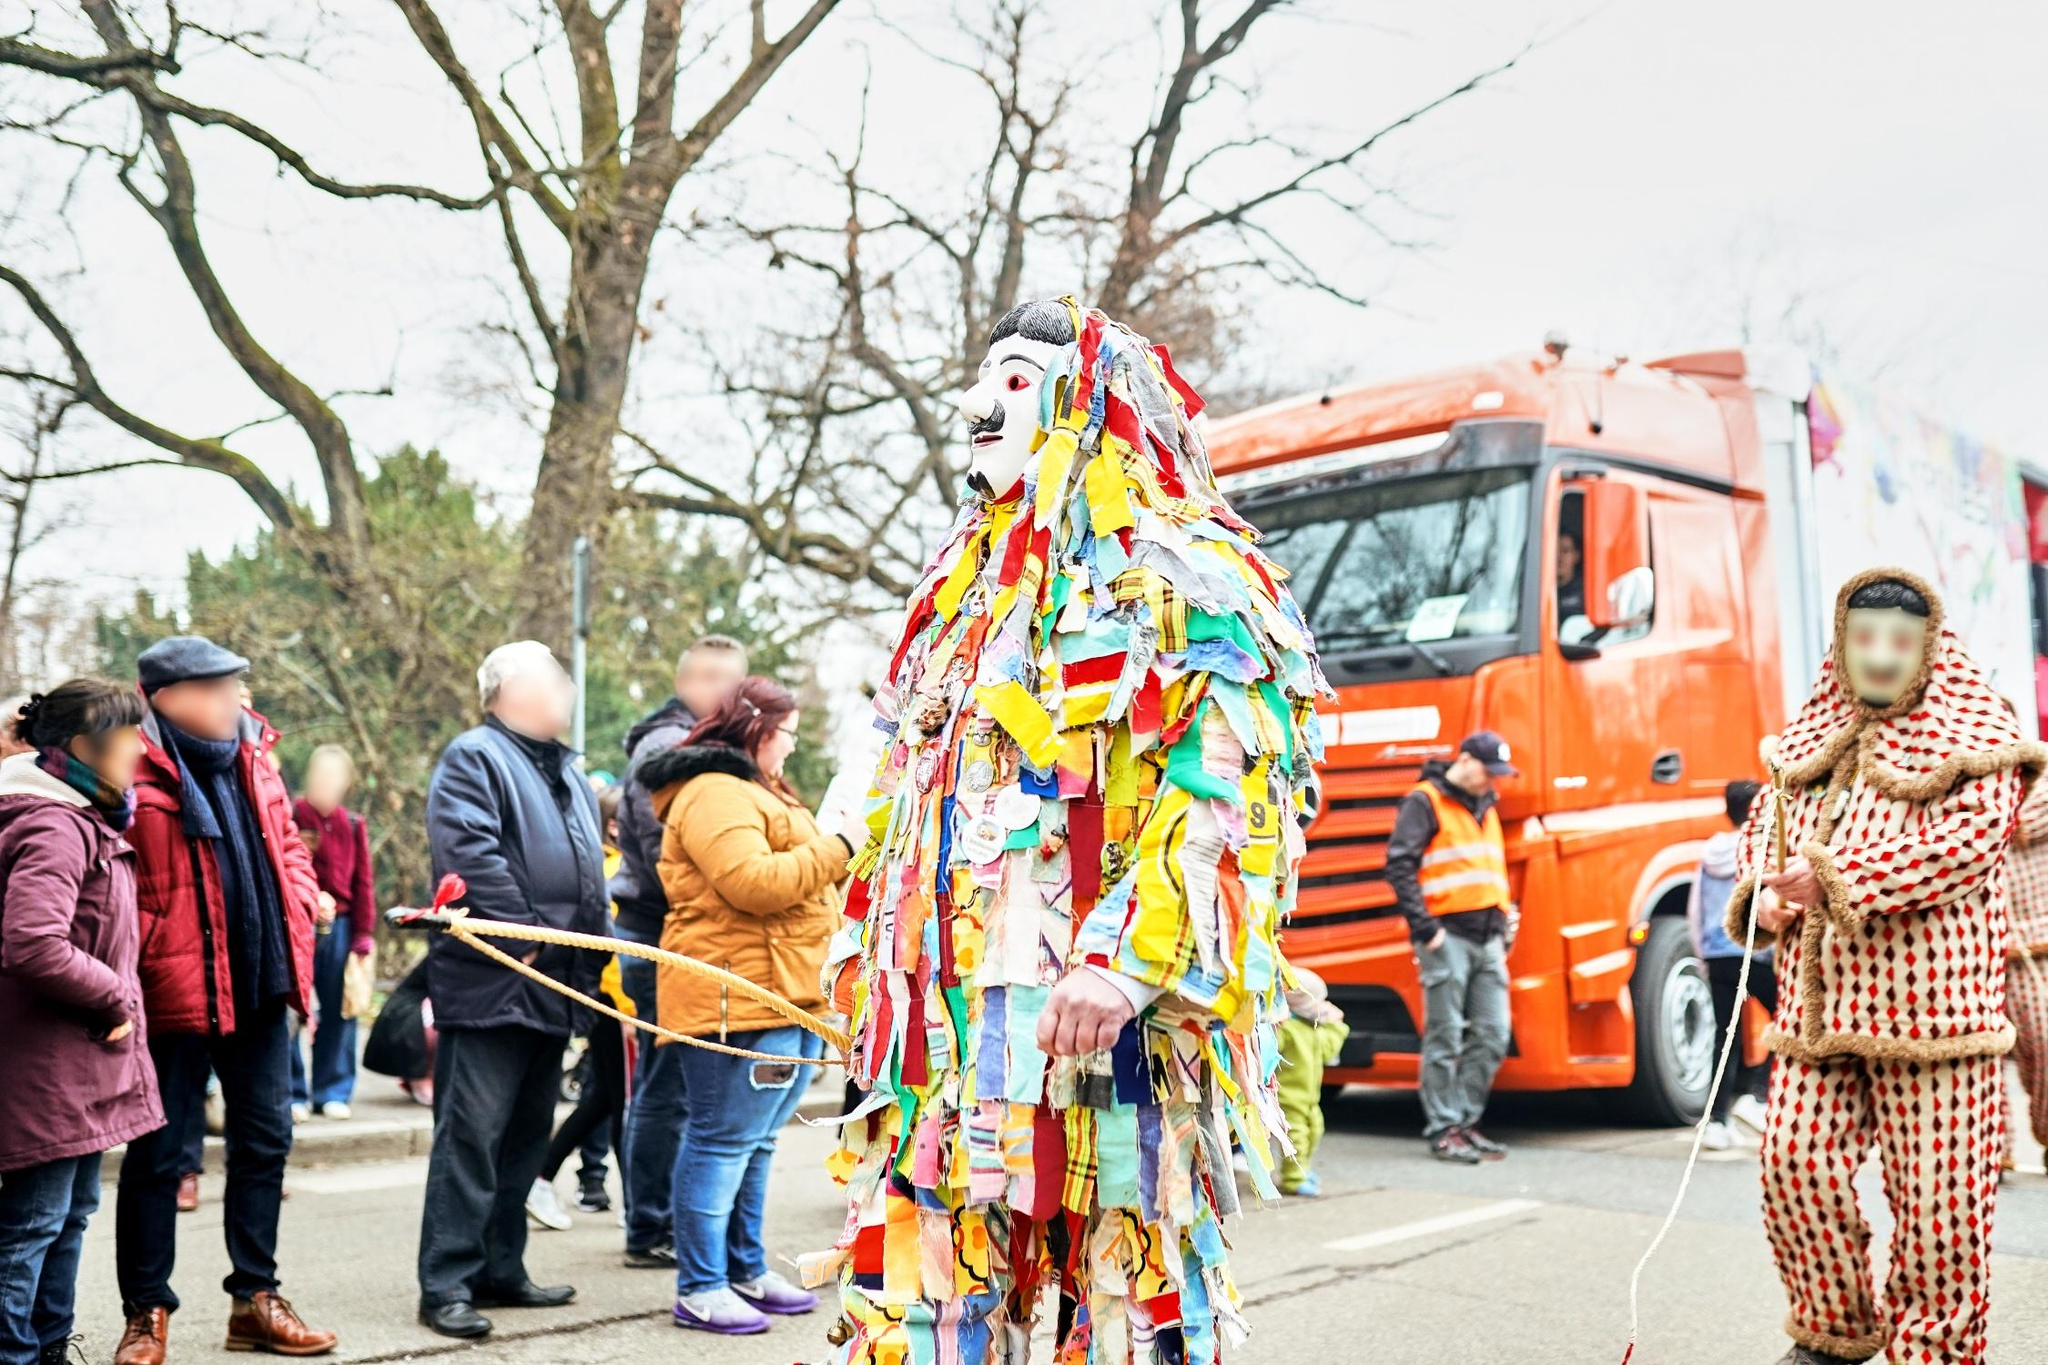What might the white mask signify in this cultural celebration? In many cultural celebrations, masks play a crucial role in representing mythological or historical figures, concealing identities to allow for uninhibited expression, or invoking certain spiritual or ceremonial significances. The white mask in the image, with its bold eye designs and vivid red lips, could symbolize purity, transformation, or anonymity, enabling the wearer to adopt a persona that embodies specific cultural narratives or themes during the parade. The mask's striking appearance against the colorful costume also accentuates the wearer's role, perhaps marking them as a key figure in the event, like a leader or a personification of the festival's spirit. 